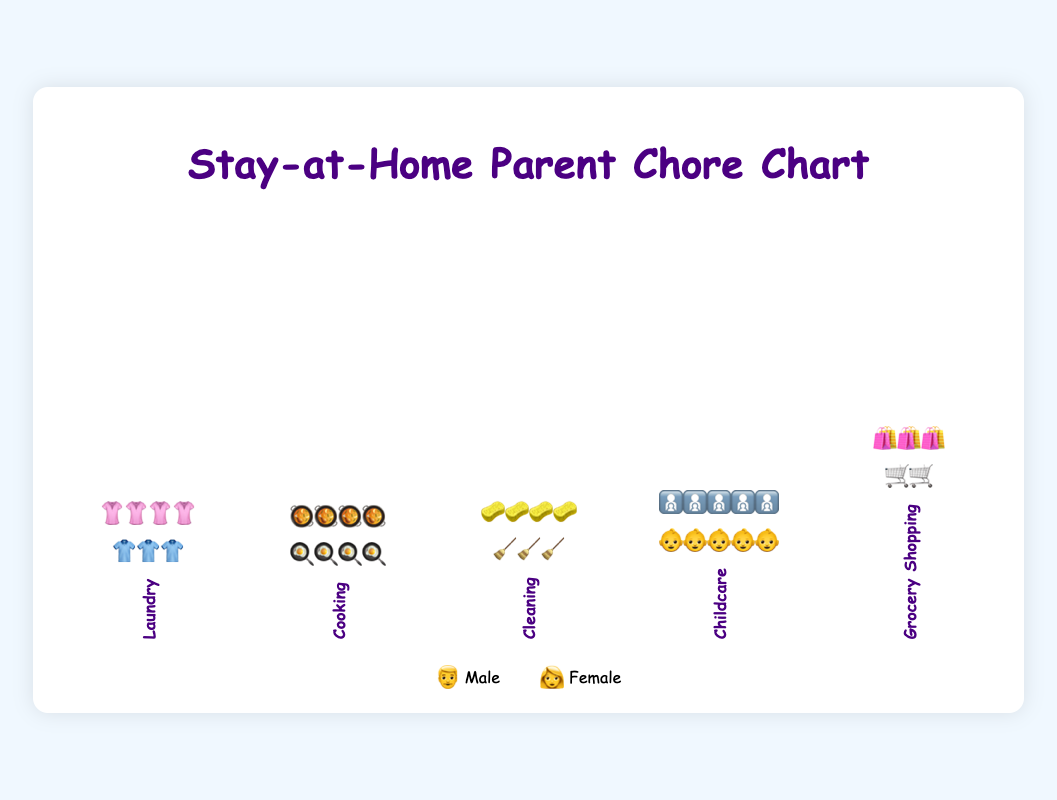What is the title of the figure? The title is typically located at the top of the chart and serves to summarize the content or the main focus.
Answer: Stay-at-Home Parent Chore Chart Which category shows female icons representing more chores than male icons? By visually scanning each category, count the number of female icons and compare them to the male icons. The category with more female icons is the answer.
Answer: Cleaning In which category do both genders perform an equal number of chores? Look at each category and compare the icons. The category with an equal number of male and female icons indicates equal participation.
Answer: Cooking Which gender performs more grocery shopping chores? Compare the number of male and female icons in the Grocery Shopping category to determine which is greater.
Answer: Female How many extra chores do females perform in the Laundry category compared to males? Subtract the number of male icons (3) from the number of female icons (4) in the Laundry category. 4 - 3 = 1
Answer: 1 What is the total number of icons representing Childcare chores? Add the number of icons for both genders in the Childcare category. Male icons = 5, Female icons = 5. 5 + 5 = 10
Answer: 10 Which category has the least number of chores performed by males? Compare the number of male icons across all categories to find the smallest number.
Answer: Grocery Shopping By how many icons does the number of Cleaning chores performed by females exceed those performed by males? Subtract the number of male icons (3) from the number of female icons (4) in the Cleaning category. 4 - 3 = 1
Answer: 1 Which two categories have the same number of chores performed by females? Identify and compare the number of female icons across all categories. Categories with the same count are the answer.
Answer: Laundry and Cooking 